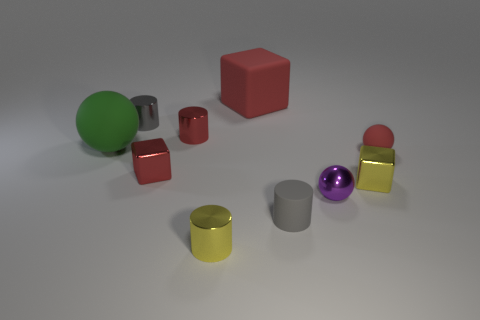Subtract all small yellow metal cylinders. How many cylinders are left? 3 Subtract all purple cylinders. How many red blocks are left? 2 Subtract all yellow cylinders. How many cylinders are left? 3 Subtract 1 cylinders. How many cylinders are left? 3 Add 3 blue balls. How many blue balls exist? 3 Subtract 1 yellow cylinders. How many objects are left? 9 Subtract all cubes. How many objects are left? 7 Subtract all blue spheres. Subtract all cyan blocks. How many spheres are left? 3 Subtract all cyan shiny things. Subtract all large red matte things. How many objects are left? 9 Add 2 metallic spheres. How many metallic spheres are left? 3 